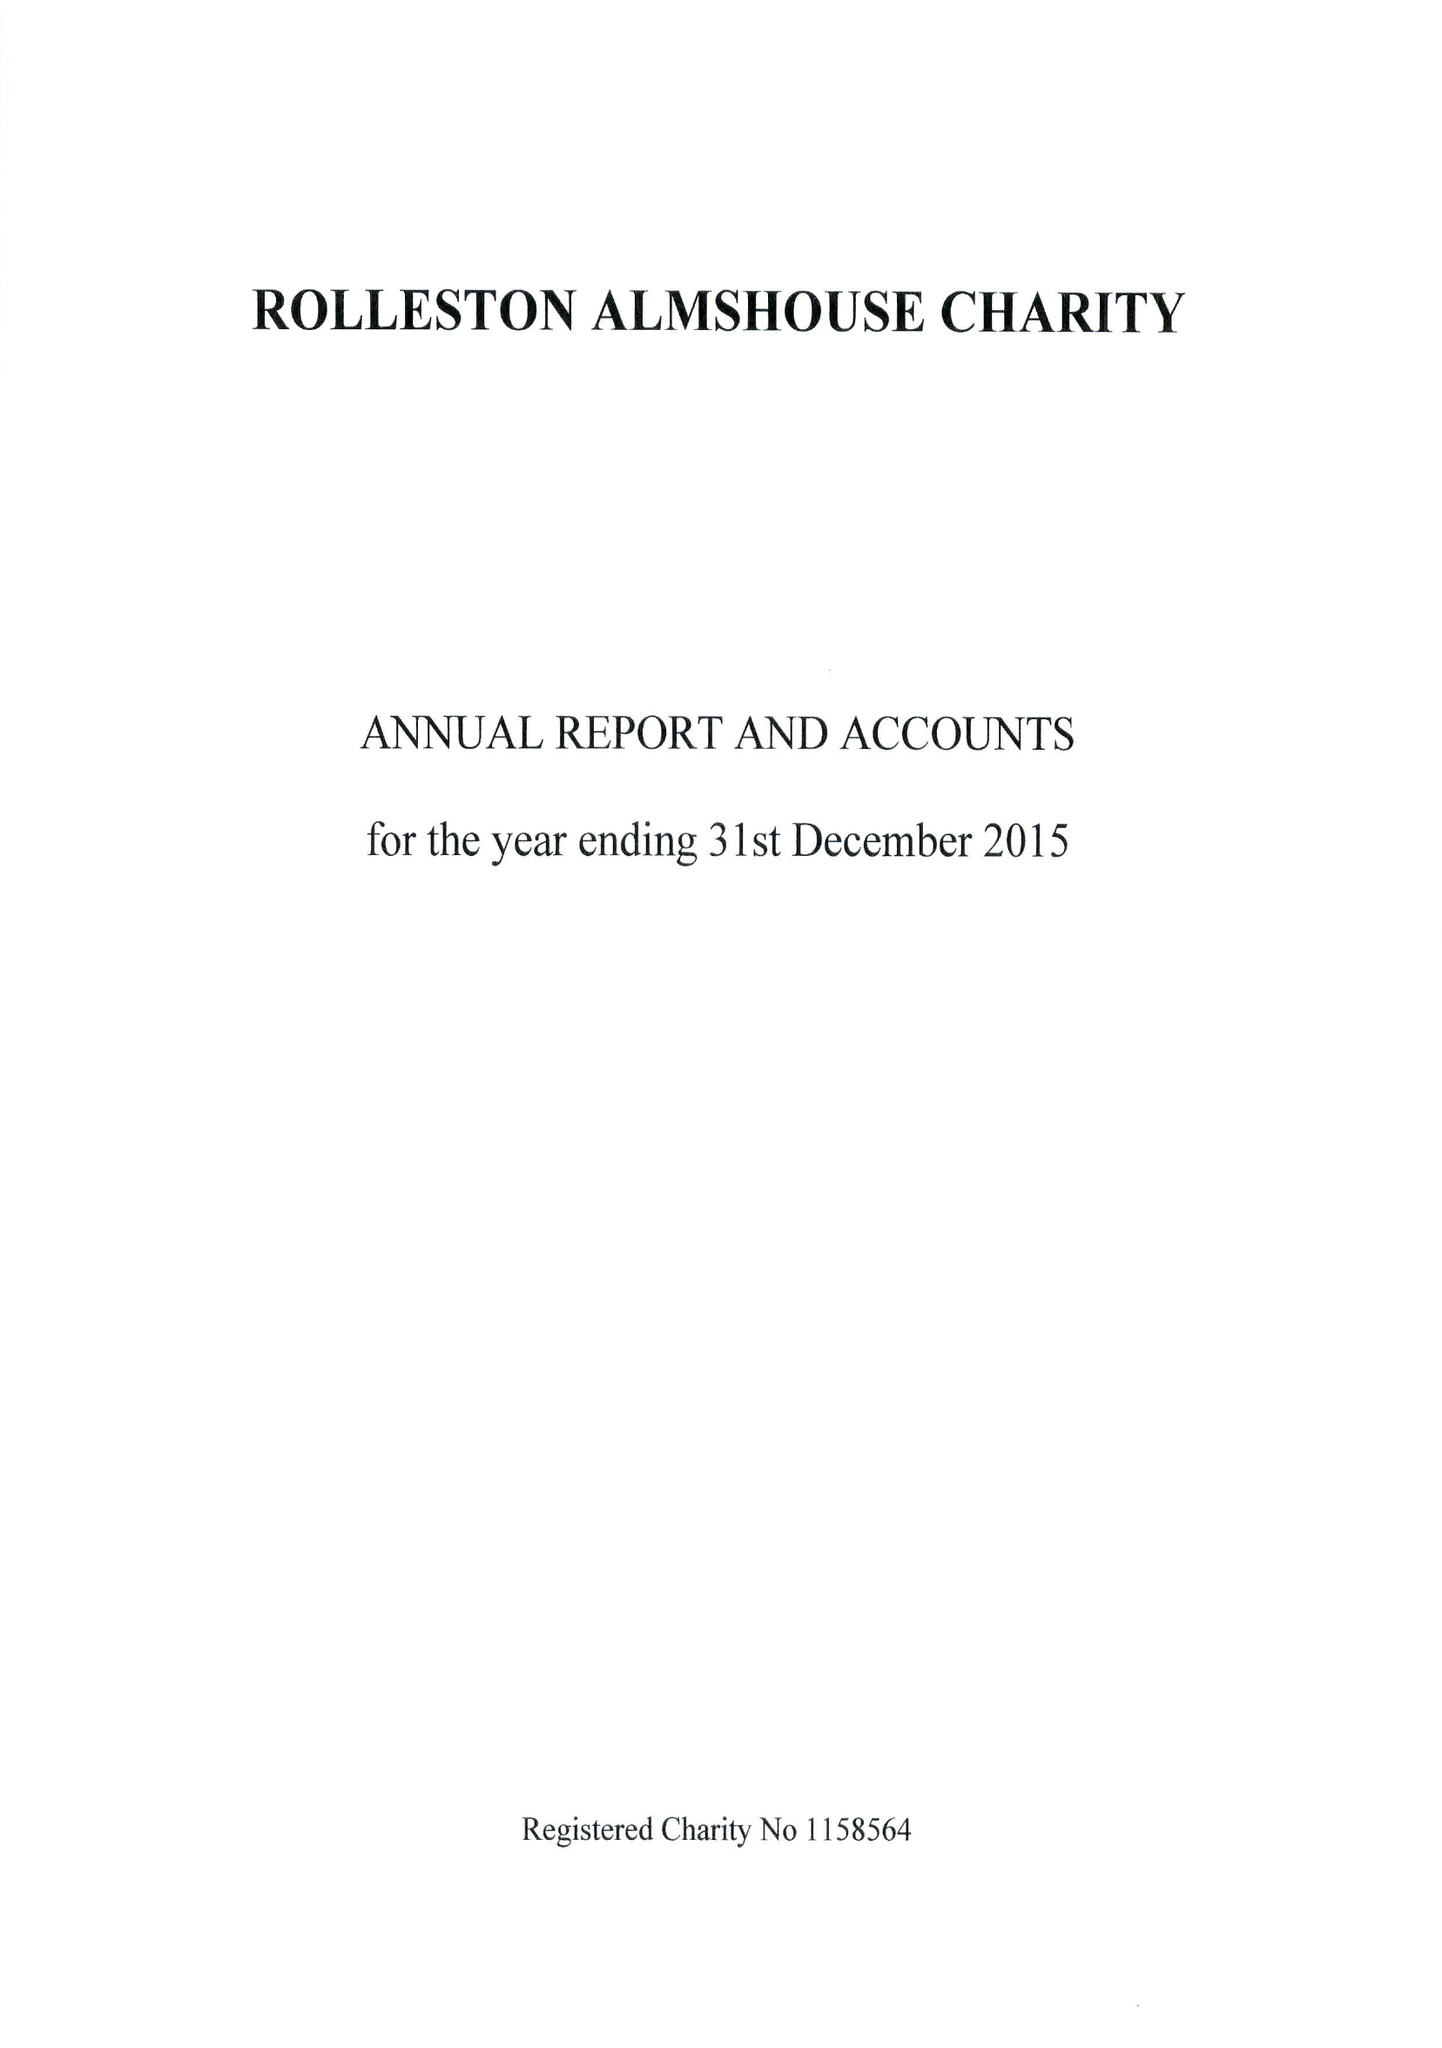What is the value for the report_date?
Answer the question using a single word or phrase. 2015-12-31 